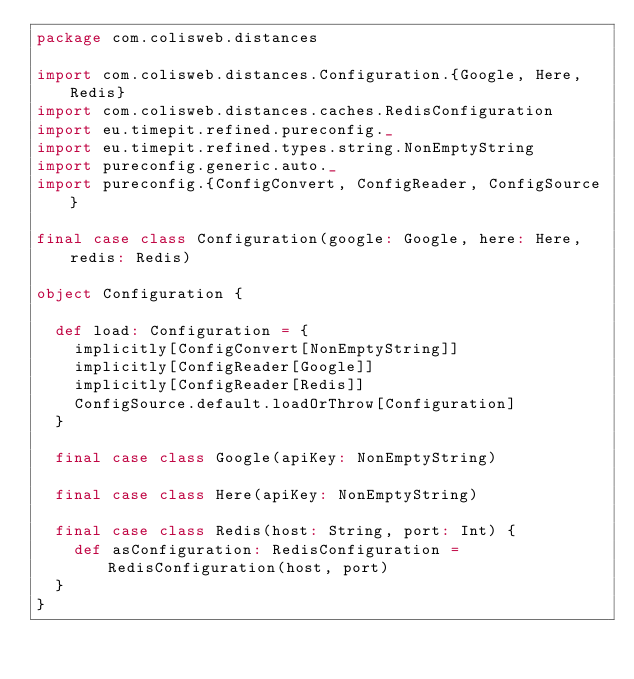<code> <loc_0><loc_0><loc_500><loc_500><_Scala_>package com.colisweb.distances

import com.colisweb.distances.Configuration.{Google, Here, Redis}
import com.colisweb.distances.caches.RedisConfiguration
import eu.timepit.refined.pureconfig._
import eu.timepit.refined.types.string.NonEmptyString
import pureconfig.generic.auto._
import pureconfig.{ConfigConvert, ConfigReader, ConfigSource}

final case class Configuration(google: Google, here: Here, redis: Redis)

object Configuration {

  def load: Configuration = {
    implicitly[ConfigConvert[NonEmptyString]]
    implicitly[ConfigReader[Google]]
    implicitly[ConfigReader[Redis]]
    ConfigSource.default.loadOrThrow[Configuration]
  }

  final case class Google(apiKey: NonEmptyString)

  final case class Here(apiKey: NonEmptyString)

  final case class Redis(host: String, port: Int) {
    def asConfiguration: RedisConfiguration = RedisConfiguration(host, port)
  }
}
</code> 